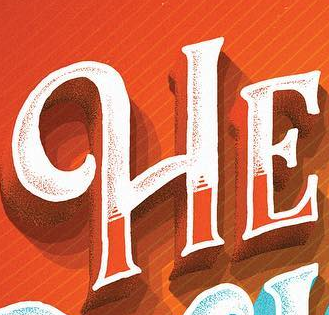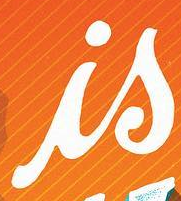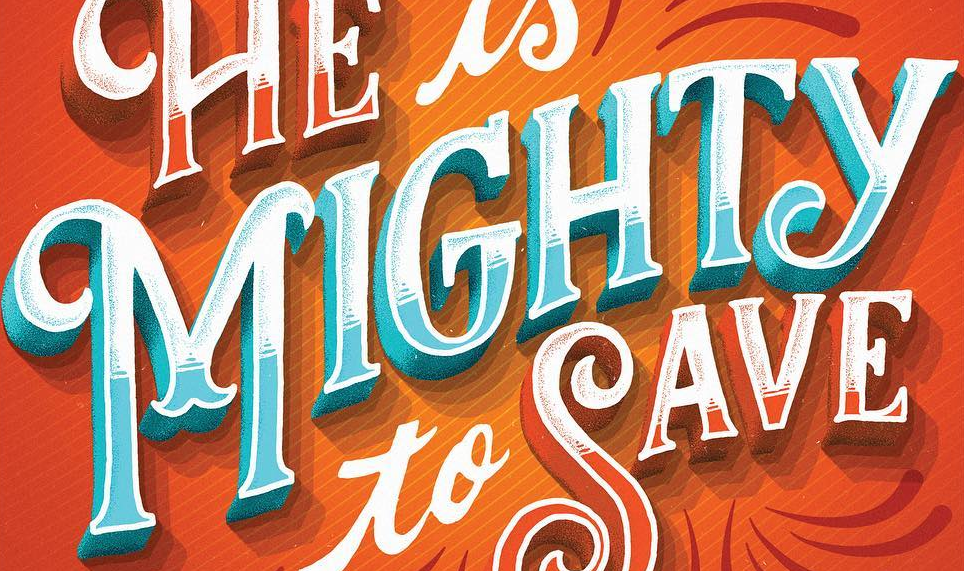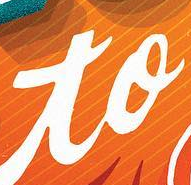What text appears in these images from left to right, separated by a semicolon? HE; is; MIGHTY; to 